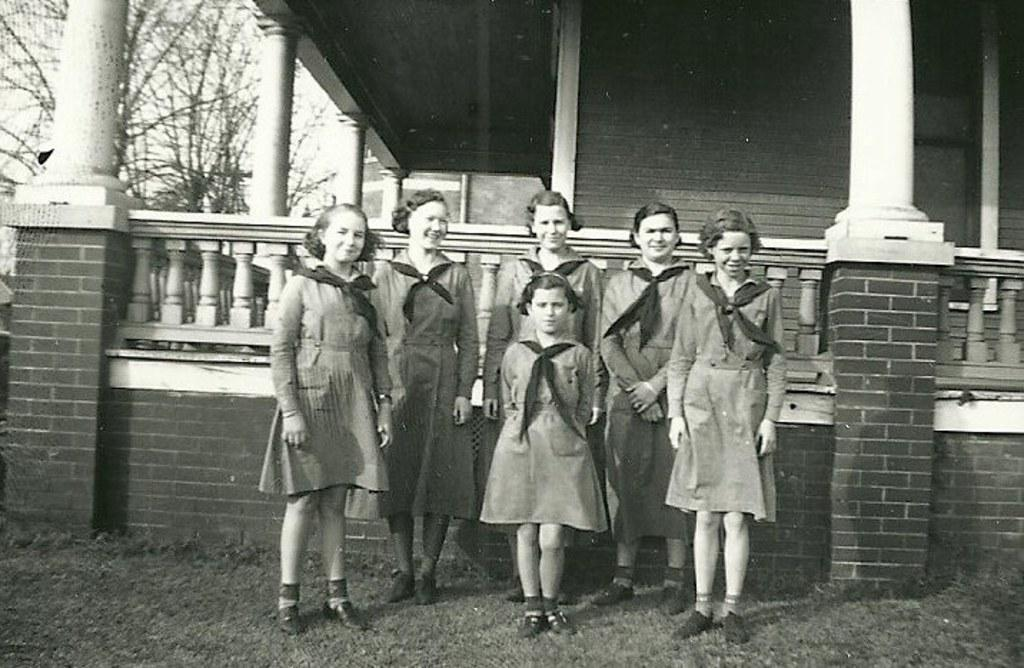What can be seen in the image? There are girls standing in the image. What are the girls wearing around their necks? The girls are wearing scarves around their necks. What is visible in the background of the image? There is a building and trees in the background of the image. What is the color scheme of the image? The image is in black and white color. What type of wall is the girls leaning against in the image? There is no wall present in the image; the girls are standing in an open area with a background of a building and trees. What team do the girls belong to in the image? There is no indication of a team affiliation in the image; the girls are simply standing with scarves around their necks. 